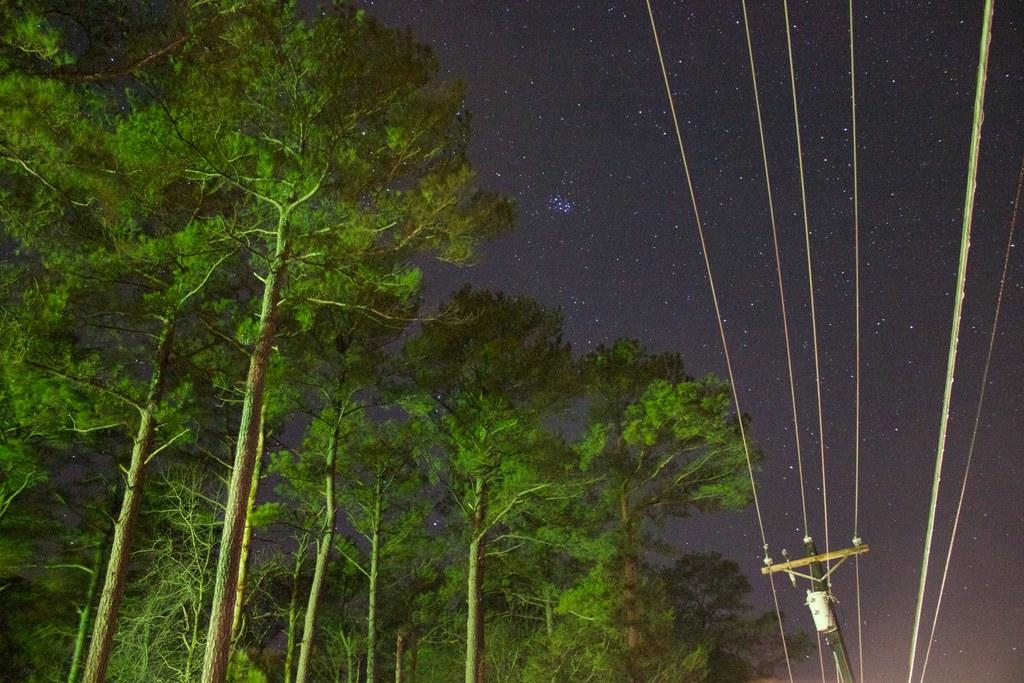What type of vegetation can be seen in the image? There are trees in the image. What else can be seen on the pole besides the trees? There are wires on a pole in the image. What is visible in the background of the image? The sky is visible in the background of the image. Can you tell me where your uncle is standing in the image? There is no uncle present in the image. What type of cherry is hanging from the trees in the image? There are no cherries present in the image; it only features trees. 